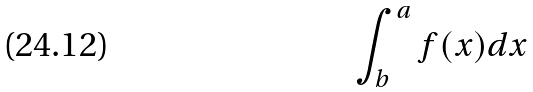<formula> <loc_0><loc_0><loc_500><loc_500>\int _ { b } ^ { a } f ( x ) d x</formula> 